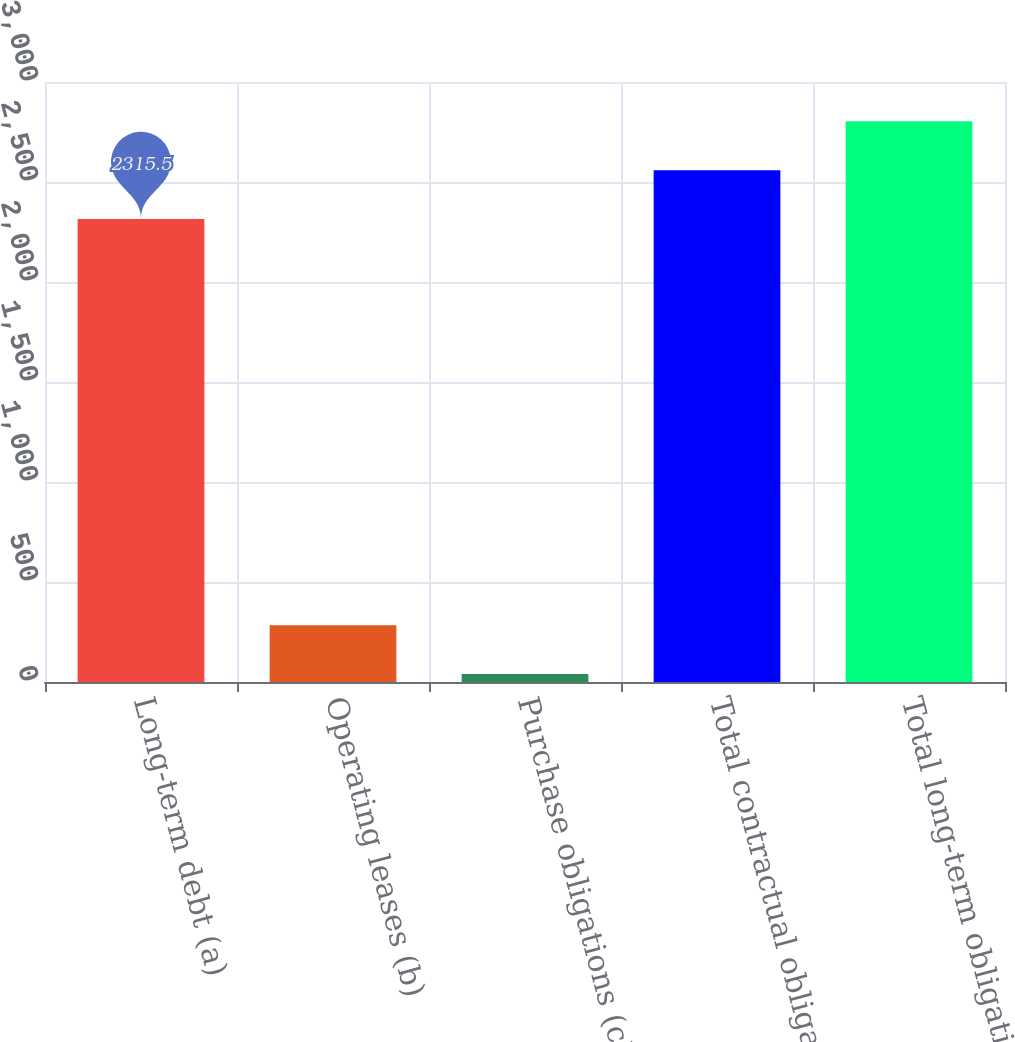Convert chart to OTSL. <chart><loc_0><loc_0><loc_500><loc_500><bar_chart><fcel>Long-term debt (a)<fcel>Operating leases (b)<fcel>Purchase obligations (c)<fcel>Total contractual obligations<fcel>Total long-term obligations<nl><fcel>2315.5<fcel>283.62<fcel>39.8<fcel>2559.32<fcel>2803.14<nl></chart> 